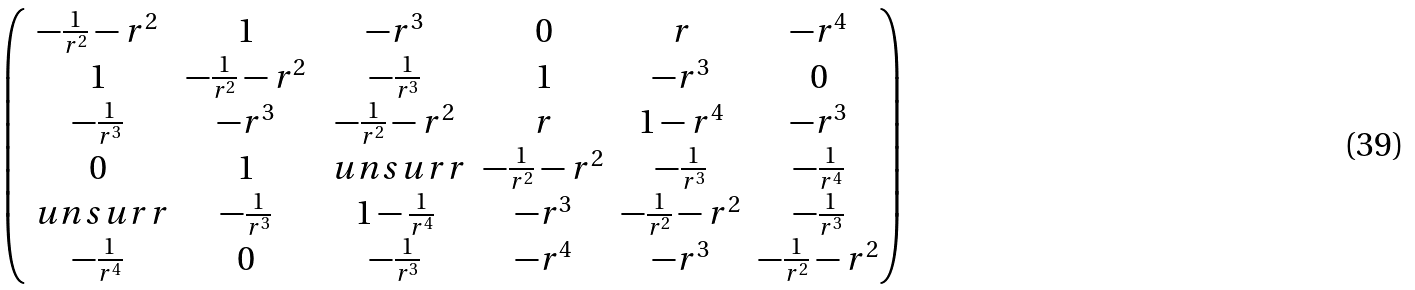Convert formula to latex. <formula><loc_0><loc_0><loc_500><loc_500>\begin{pmatrix} - \frac { 1 } { r ^ { 2 } } - r ^ { 2 } & 1 & - r ^ { 3 } & 0 & r & - r ^ { 4 } \\ 1 & - \frac { 1 } { r ^ { 2 } } - r ^ { 2 } & - \frac { 1 } { r ^ { 3 } } & 1 & - r ^ { 3 } & 0 \\ - \frac { 1 } { r ^ { 3 } } & - r ^ { 3 } & - \frac { 1 } { r ^ { 2 } } - r ^ { 2 } & r & 1 - r ^ { 4 } & - r ^ { 3 } \\ 0 & 1 & \ u n s u r r & - \frac { 1 } { r ^ { 2 } } - r ^ { 2 } & - \frac { 1 } { r ^ { 3 } } & - \frac { 1 } { r ^ { 4 } } \\ \ u n s u r r & - \frac { 1 } { r ^ { 3 } } & 1 - \frac { 1 } { r ^ { 4 } } & - r ^ { 3 } & - \frac { 1 } { r ^ { 2 } } - r ^ { 2 } & - \frac { 1 } { r ^ { 3 } } \\ - \frac { 1 } { r ^ { 4 } } & 0 & - \frac { 1 } { r ^ { 3 } } & - r ^ { 4 } & - r ^ { 3 } & - \frac { 1 } { r ^ { 2 } } - r ^ { 2 } \end{pmatrix}</formula> 